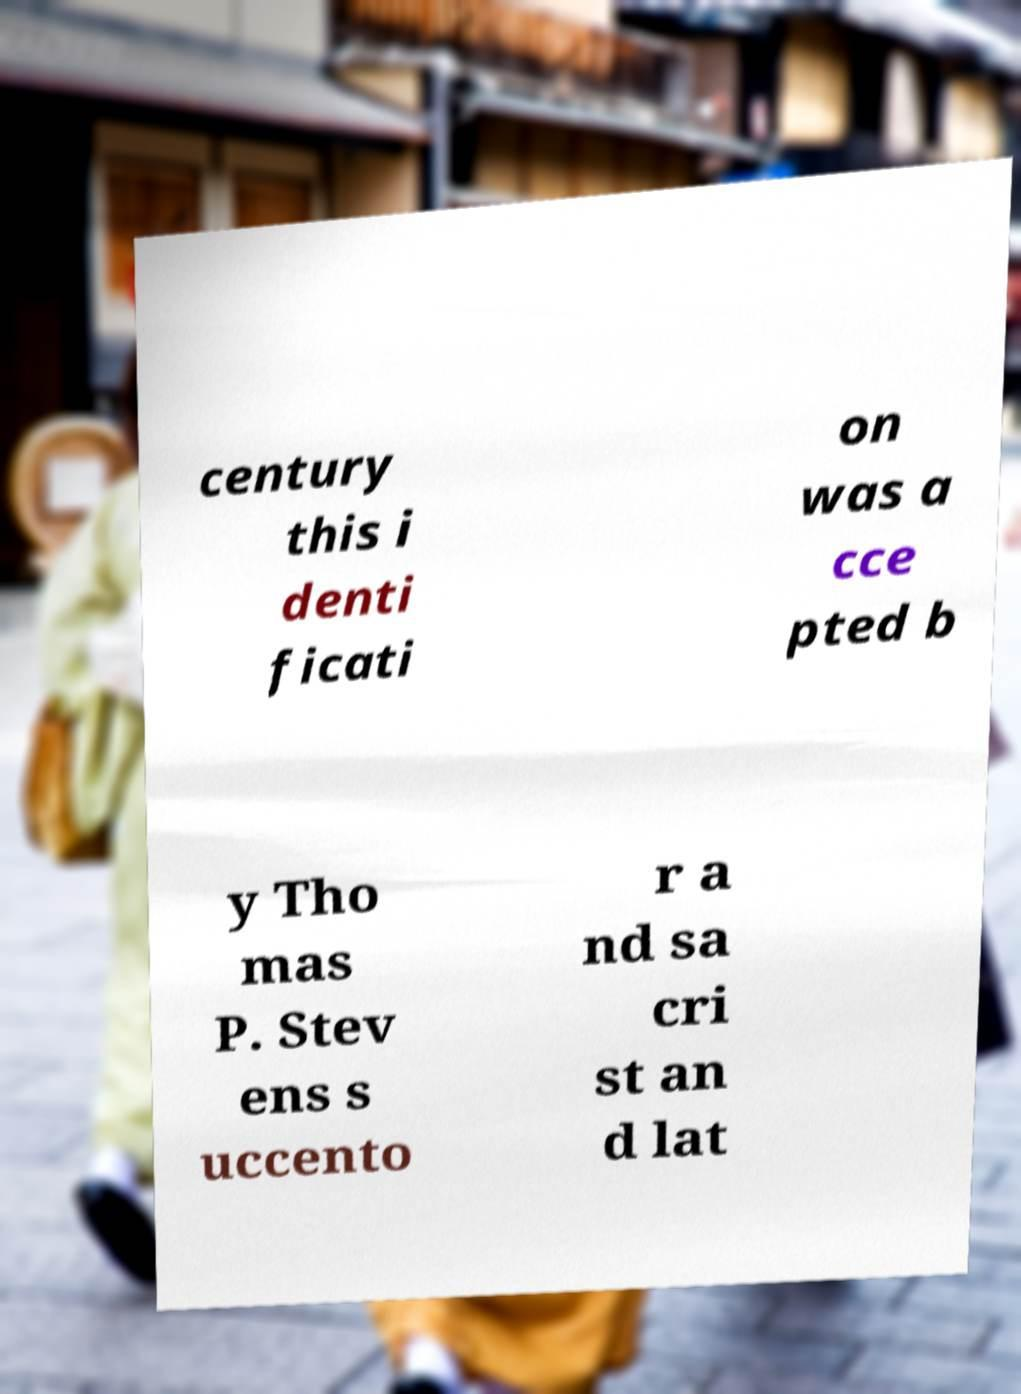Can you accurately transcribe the text from the provided image for me? century this i denti ficati on was a cce pted b y Tho mas P. Stev ens s uccento r a nd sa cri st an d lat 